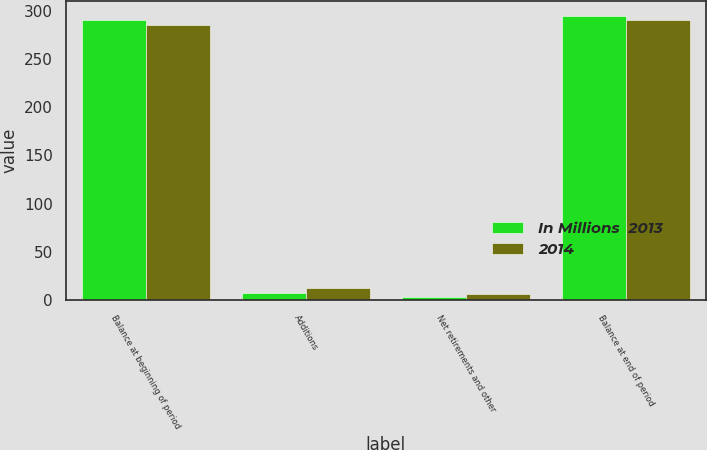<chart> <loc_0><loc_0><loc_500><loc_500><stacked_bar_chart><ecel><fcel>Balance at beginning of period<fcel>Additions<fcel>Net retirements and other<fcel>Balance at end of period<nl><fcel>In Millions  2013<fcel>291<fcel>7<fcel>3<fcel>295<nl><fcel>2014<fcel>285<fcel>12<fcel>6<fcel>291<nl></chart> 